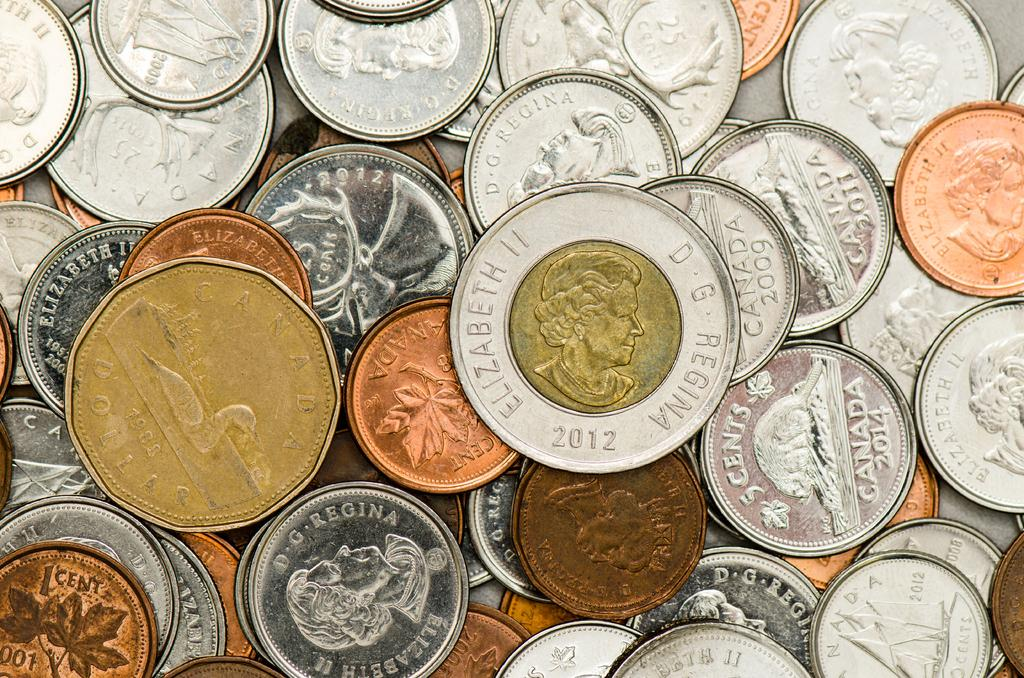Provide a one-sentence caption for the provided image. Coins of various colors and shapes are sitting in a pile together with a 2012 Canadian Elizabeth II sitting on top. 